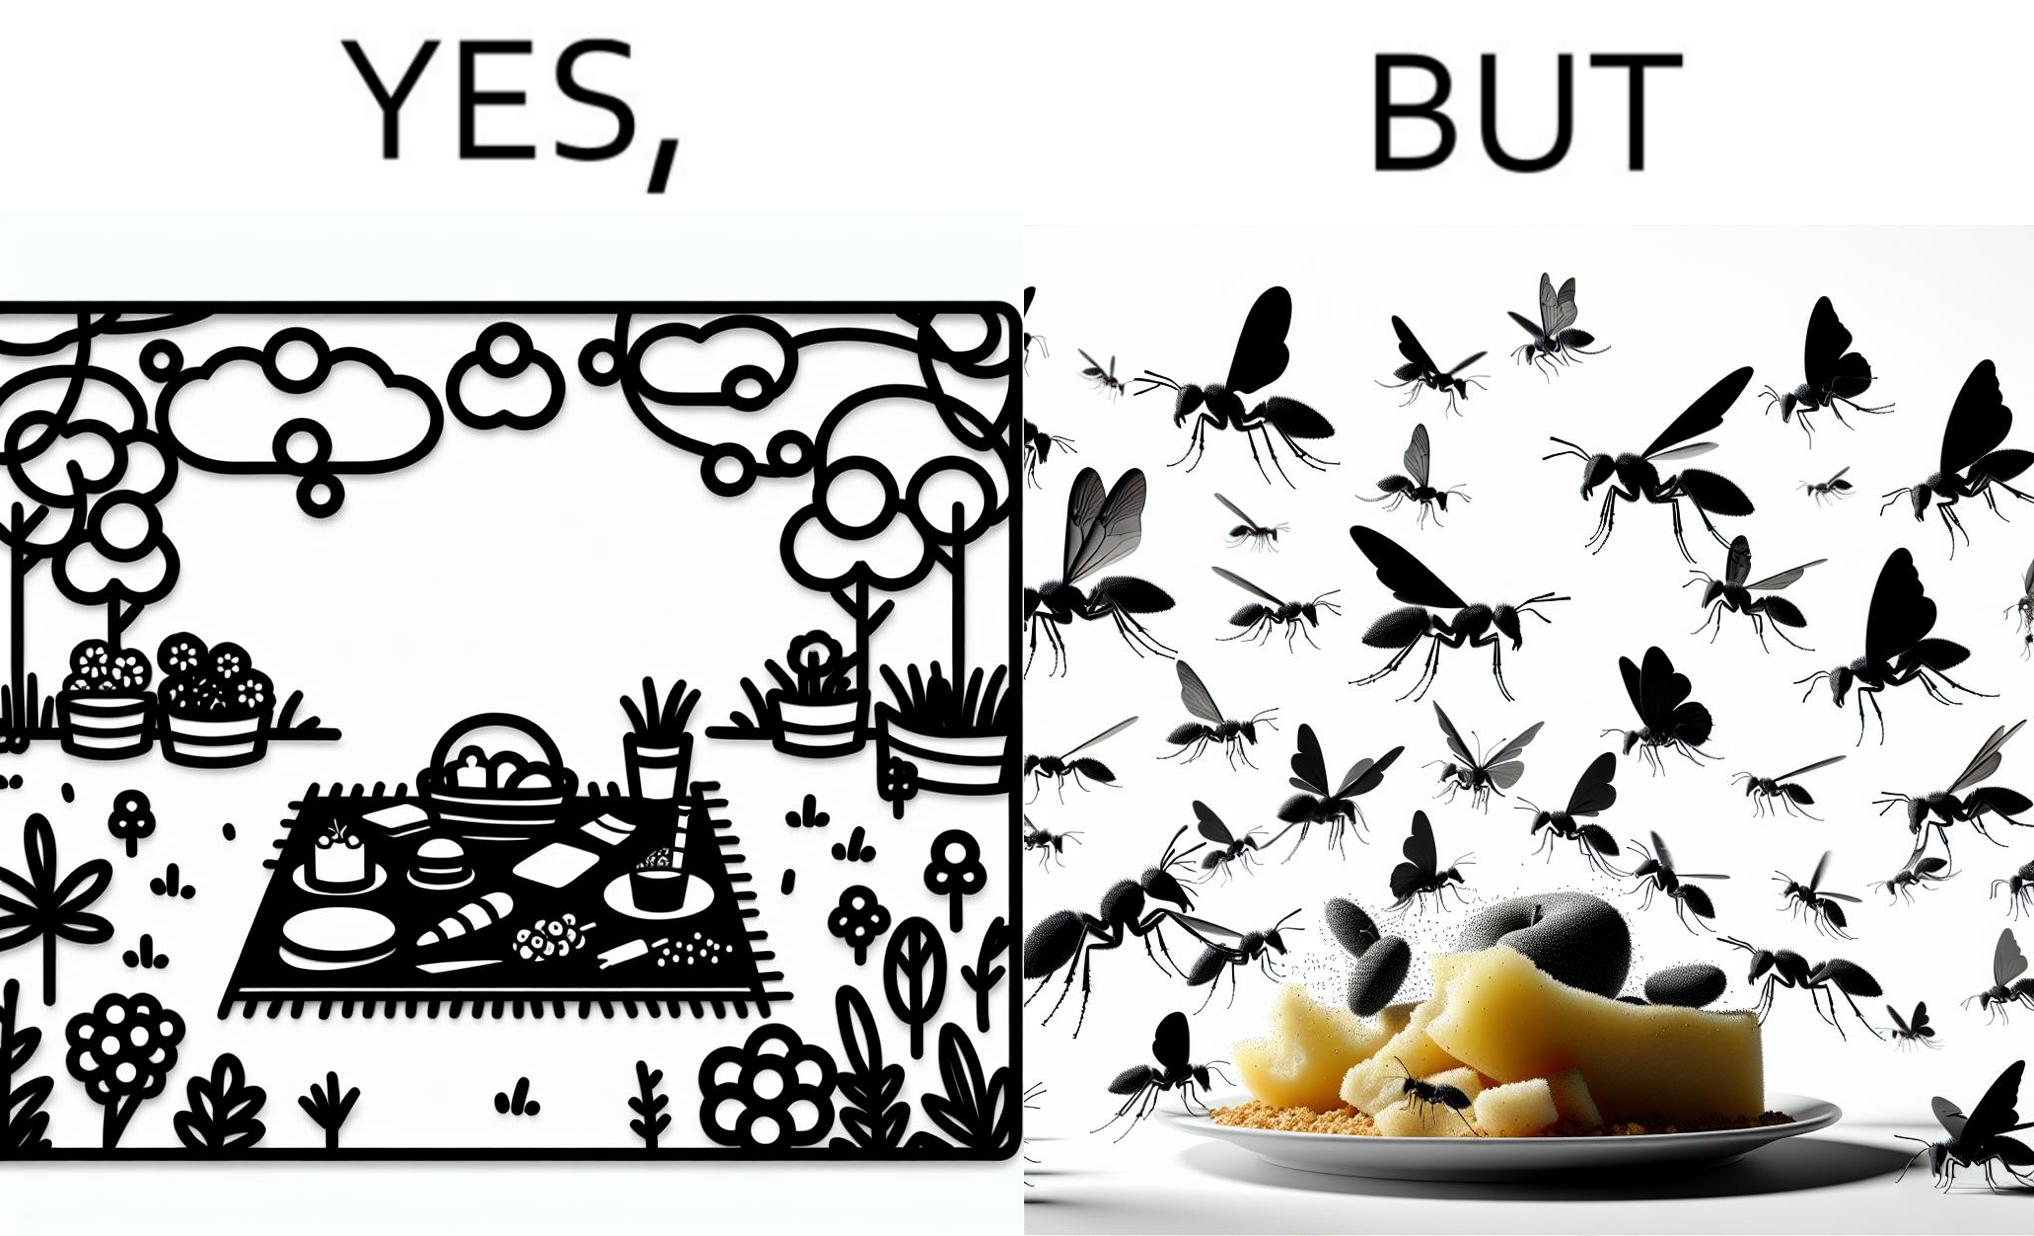What is shown in this image? The Picture shows that although we enjoy food in garden but there are some consequences of eating food in garden. Many bugs and bees are attracted towards our food and make our food sometimes non-eatable. 